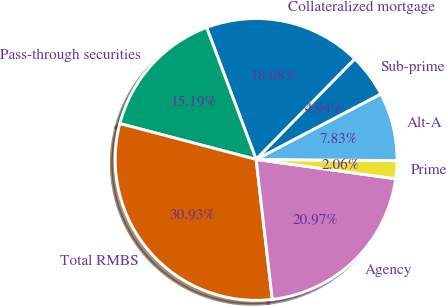Convert chart. <chart><loc_0><loc_0><loc_500><loc_500><pie_chart><fcel>Collateralized mortgage<fcel>Pass-through securities<fcel>Total RMBS<fcel>Agency<fcel>Prime<fcel>Alt-A<fcel>Sub-prime<nl><fcel>18.08%<fcel>15.19%<fcel>30.93%<fcel>20.97%<fcel>2.06%<fcel>7.83%<fcel>4.94%<nl></chart> 